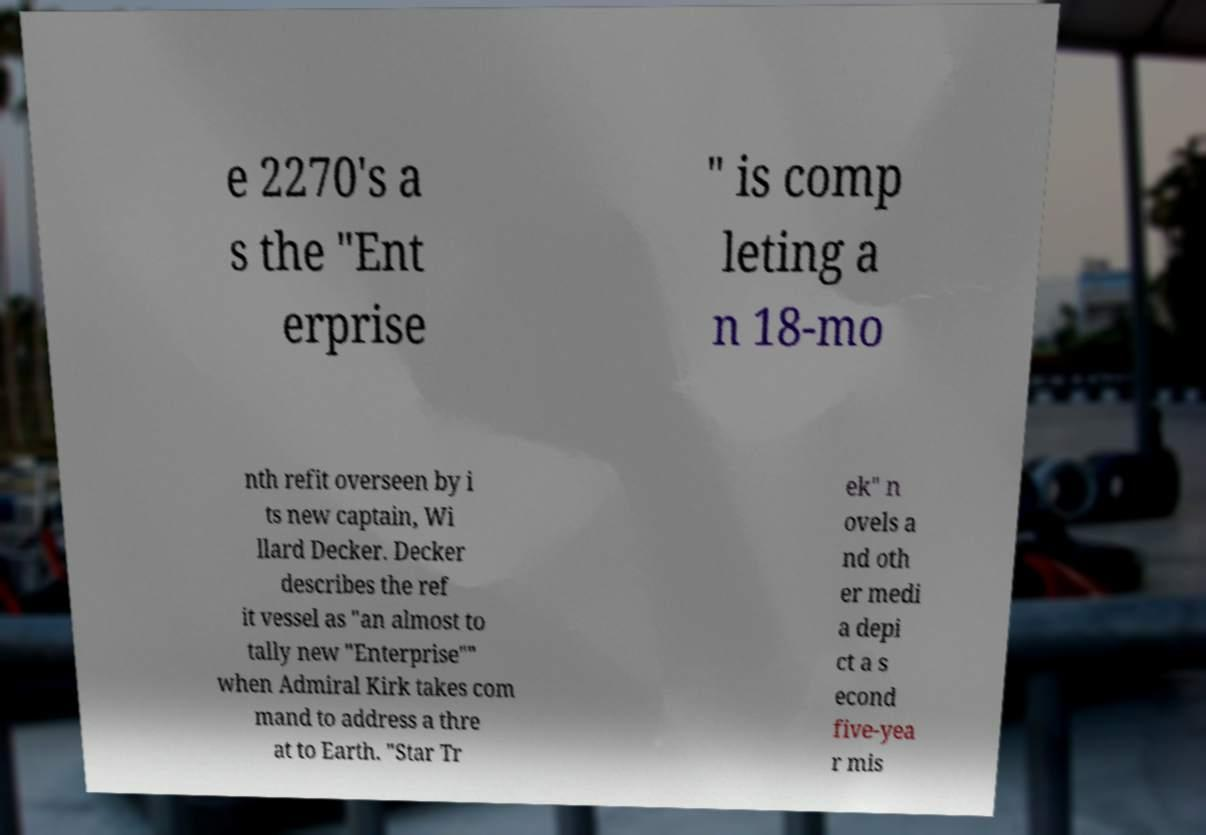What messages or text are displayed in this image? I need them in a readable, typed format. e 2270's a s the "Ent erprise " is comp leting a n 18-mo nth refit overseen by i ts new captain, Wi llard Decker. Decker describes the ref it vessel as "an almost to tally new "Enterprise"" when Admiral Kirk takes com mand to address a thre at to Earth. "Star Tr ek" n ovels a nd oth er medi a depi ct a s econd five-yea r mis 